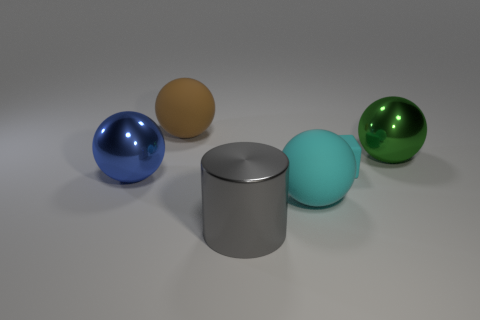Subtract all big brown spheres. How many spheres are left? 3 Subtract all blue balls. How many balls are left? 3 Subtract 1 balls. How many balls are left? 3 Subtract all cyan spheres. Subtract all brown cylinders. How many spheres are left? 3 Subtract all blocks. How many objects are left? 5 Add 2 yellow matte cylinders. How many objects exist? 8 Add 5 big cylinders. How many big cylinders exist? 6 Subtract 0 cyan cylinders. How many objects are left? 6 Subtract all cyan cubes. Subtract all large cyan rubber objects. How many objects are left? 4 Add 1 big rubber things. How many big rubber things are left? 3 